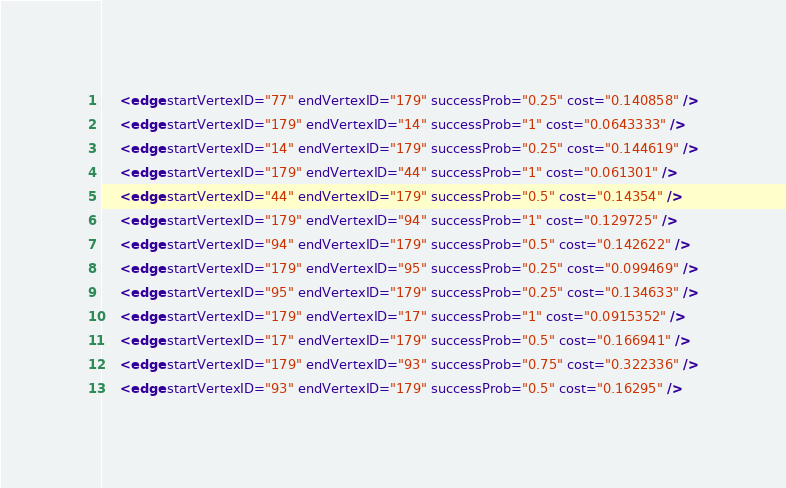Convert code to text. <code><loc_0><loc_0><loc_500><loc_500><_XML_>    <edge startVertexID="77" endVertexID="179" successProb="0.25" cost="0.140858" />
    <edge startVertexID="179" endVertexID="14" successProb="1" cost="0.0643333" />
    <edge startVertexID="14" endVertexID="179" successProb="0.25" cost="0.144619" />
    <edge startVertexID="179" endVertexID="44" successProb="1" cost="0.061301" />
    <edge startVertexID="44" endVertexID="179" successProb="0.5" cost="0.14354" />
    <edge startVertexID="179" endVertexID="94" successProb="1" cost="0.129725" />
    <edge startVertexID="94" endVertexID="179" successProb="0.5" cost="0.142622" />
    <edge startVertexID="179" endVertexID="95" successProb="0.25" cost="0.099469" />
    <edge startVertexID="95" endVertexID="179" successProb="0.25" cost="0.134633" />
    <edge startVertexID="179" endVertexID="17" successProb="1" cost="0.0915352" />
    <edge startVertexID="17" endVertexID="179" successProb="0.5" cost="0.166941" />
    <edge startVertexID="179" endVertexID="93" successProb="0.75" cost="0.322336" />
    <edge startVertexID="93" endVertexID="179" successProb="0.5" cost="0.16295" /></code> 